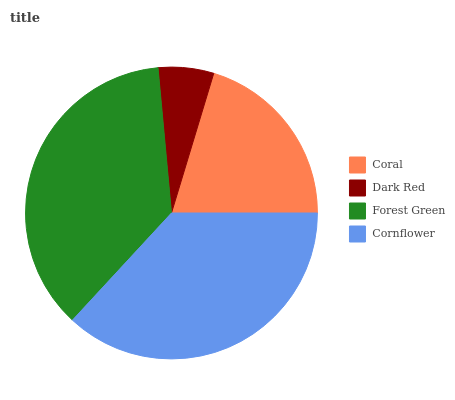Is Dark Red the minimum?
Answer yes or no. Yes. Is Cornflower the maximum?
Answer yes or no. Yes. Is Forest Green the minimum?
Answer yes or no. No. Is Forest Green the maximum?
Answer yes or no. No. Is Forest Green greater than Dark Red?
Answer yes or no. Yes. Is Dark Red less than Forest Green?
Answer yes or no. Yes. Is Dark Red greater than Forest Green?
Answer yes or no. No. Is Forest Green less than Dark Red?
Answer yes or no. No. Is Forest Green the high median?
Answer yes or no. Yes. Is Coral the low median?
Answer yes or no. Yes. Is Dark Red the high median?
Answer yes or no. No. Is Forest Green the low median?
Answer yes or no. No. 